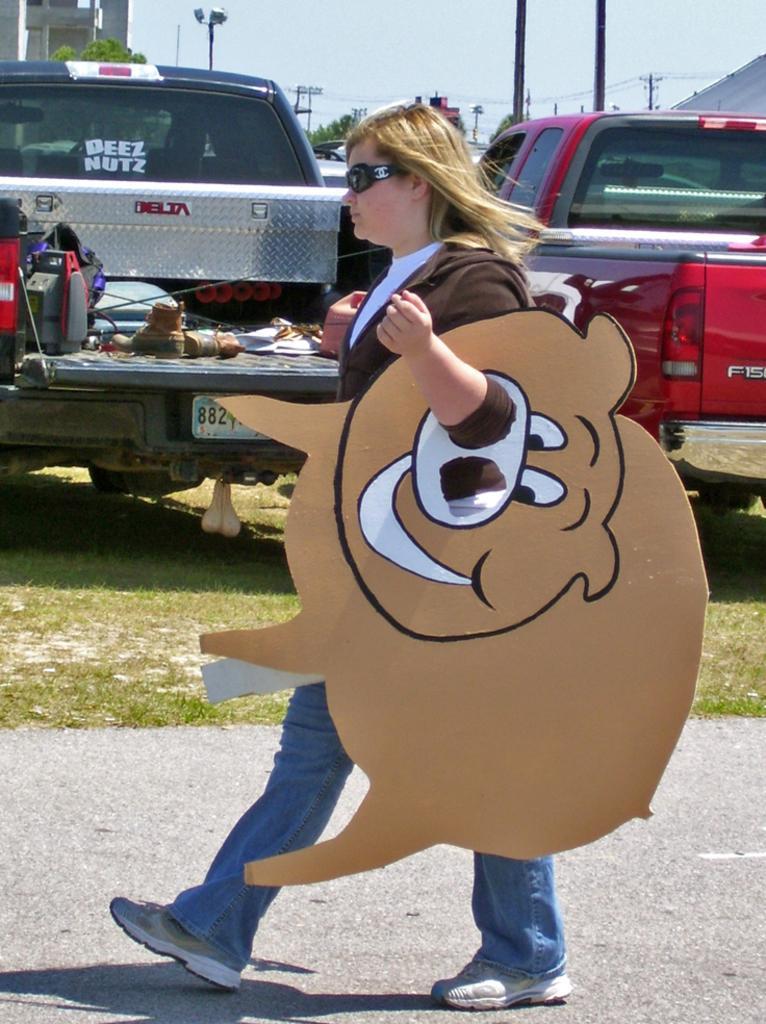In one or two sentences, can you explain what this image depicts? In the middle of the image we can see a woman, she is walking, she wore spectacles and she is holding a cardboard, in the background we can see few vehicles, buildings, trees, poles and cables. 